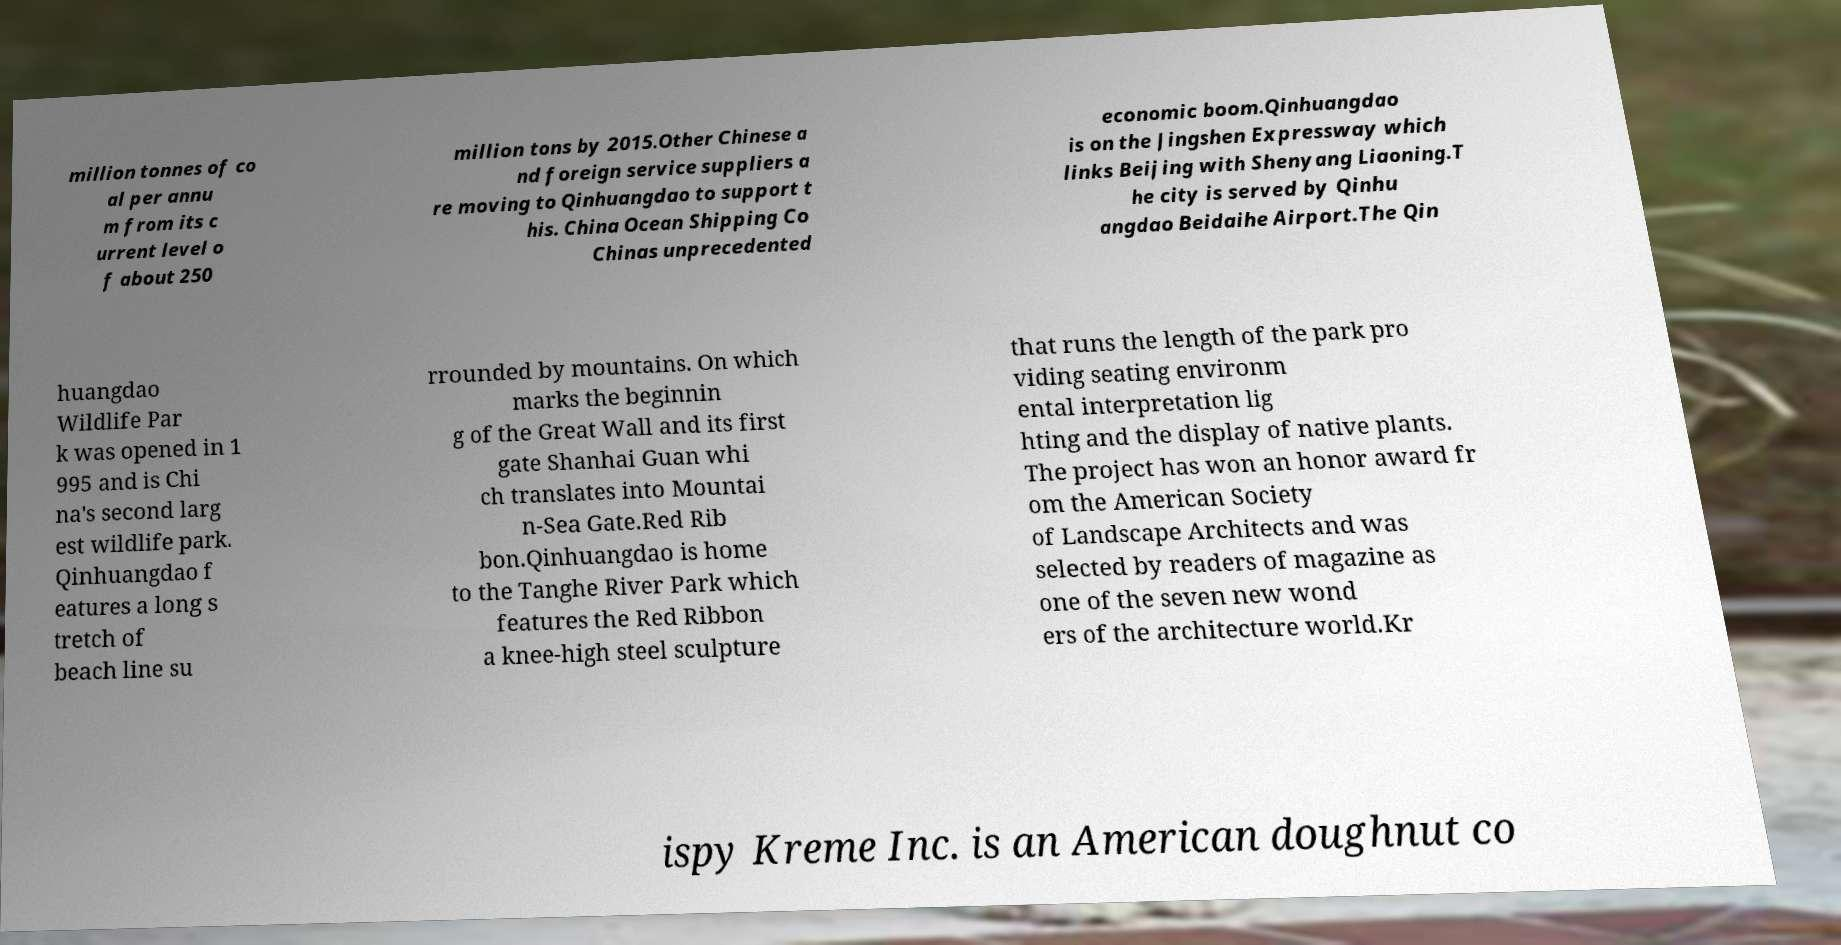Can you read and provide the text displayed in the image?This photo seems to have some interesting text. Can you extract and type it out for me? million tonnes of co al per annu m from its c urrent level o f about 250 million tons by 2015.Other Chinese a nd foreign service suppliers a re moving to Qinhuangdao to support t his. China Ocean Shipping Co Chinas unprecedented economic boom.Qinhuangdao is on the Jingshen Expressway which links Beijing with Shenyang Liaoning.T he city is served by Qinhu angdao Beidaihe Airport.The Qin huangdao Wildlife Par k was opened in 1 995 and is Chi na's second larg est wildlife park. Qinhuangdao f eatures a long s tretch of beach line su rrounded by mountains. On which marks the beginnin g of the Great Wall and its first gate Shanhai Guan whi ch translates into Mountai n-Sea Gate.Red Rib bon.Qinhuangdao is home to the Tanghe River Park which features the Red Ribbon a knee-high steel sculpture that runs the length of the park pro viding seating environm ental interpretation lig hting and the display of native plants. The project has won an honor award fr om the American Society of Landscape Architects and was selected by readers of magazine as one of the seven new wond ers of the architecture world.Kr ispy Kreme Inc. is an American doughnut co 